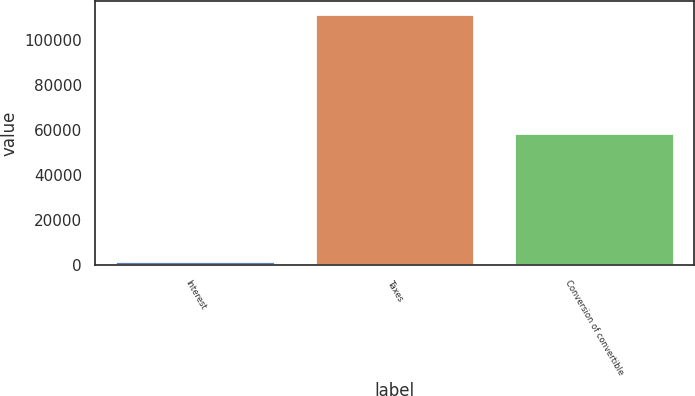Convert chart to OTSL. <chart><loc_0><loc_0><loc_500><loc_500><bar_chart><fcel>Interest<fcel>Taxes<fcel>Conversion of convertible<nl><fcel>1631<fcel>111778<fcel>58752<nl></chart> 